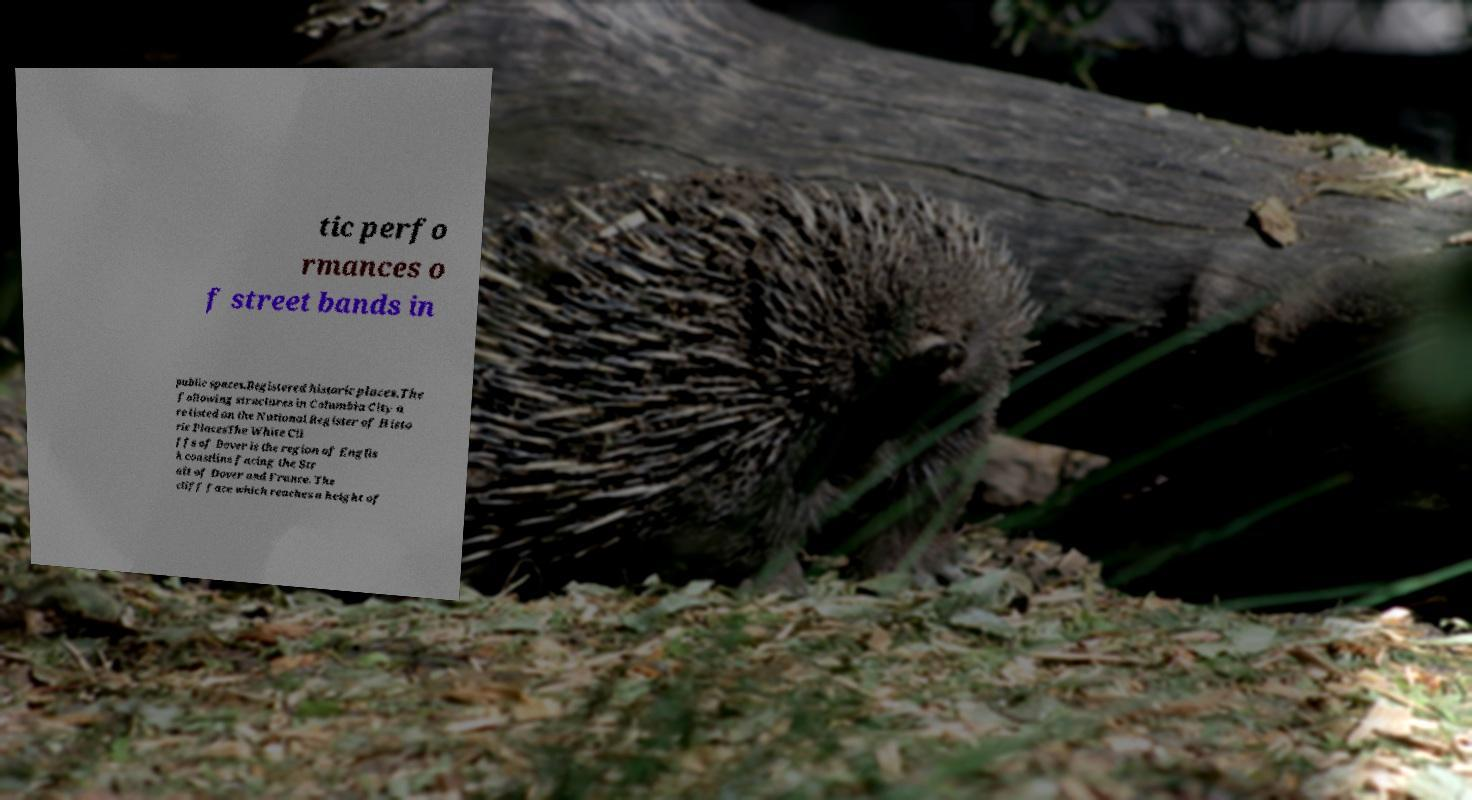I need the written content from this picture converted into text. Can you do that? tic perfo rmances o f street bands in public spaces.Registered historic places.The following structures in Columbia City a re listed on the National Register of Histo ric PlacesThe White Cli ffs of Dover is the region of Englis h coastline facing the Str ait of Dover and France. The cliff face which reaches a height of 